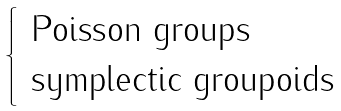<formula> <loc_0><loc_0><loc_500><loc_500>\begin{cases} \text { Poisson groups} \\ \text { symplectic groupoids} \end{cases}</formula> 